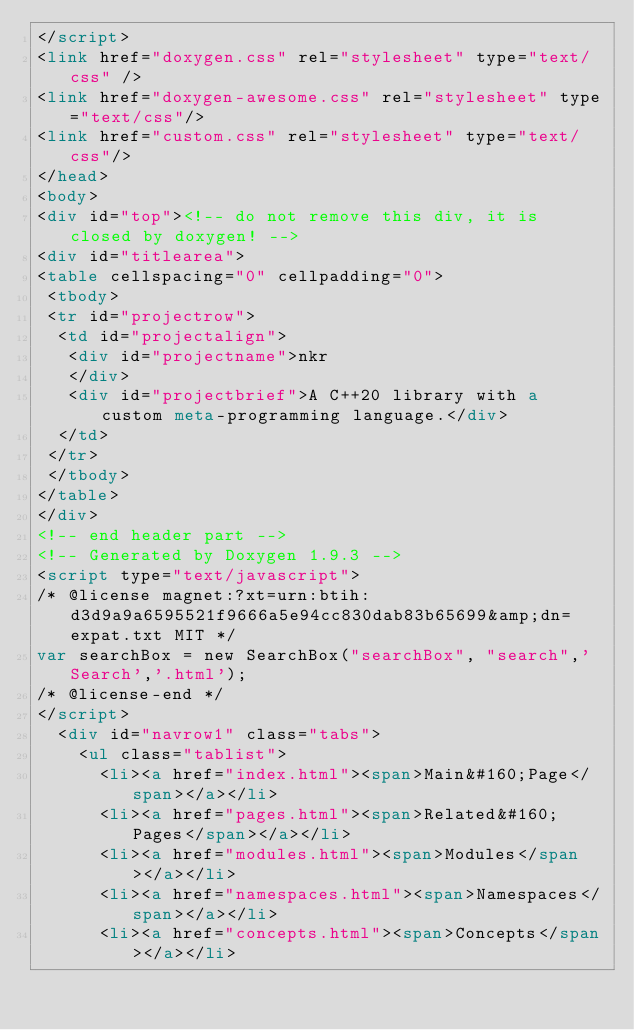<code> <loc_0><loc_0><loc_500><loc_500><_HTML_></script>
<link href="doxygen.css" rel="stylesheet" type="text/css" />
<link href="doxygen-awesome.css" rel="stylesheet" type="text/css"/>
<link href="custom.css" rel="stylesheet" type="text/css"/>
</head>
<body>
<div id="top"><!-- do not remove this div, it is closed by doxygen! -->
<div id="titlearea">
<table cellspacing="0" cellpadding="0">
 <tbody>
 <tr id="projectrow">
  <td id="projectalign">
   <div id="projectname">nkr
   </div>
   <div id="projectbrief">A C++20 library with a custom meta-programming language.</div>
  </td>
 </tr>
 </tbody>
</table>
</div>
<!-- end header part -->
<!-- Generated by Doxygen 1.9.3 -->
<script type="text/javascript">
/* @license magnet:?xt=urn:btih:d3d9a9a6595521f9666a5e94cc830dab83b65699&amp;dn=expat.txt MIT */
var searchBox = new SearchBox("searchBox", "search",'Search','.html');
/* @license-end */
</script>
  <div id="navrow1" class="tabs">
    <ul class="tablist">
      <li><a href="index.html"><span>Main&#160;Page</span></a></li>
      <li><a href="pages.html"><span>Related&#160;Pages</span></a></li>
      <li><a href="modules.html"><span>Modules</span></a></li>
      <li><a href="namespaces.html"><span>Namespaces</span></a></li>
      <li><a href="concepts.html"><span>Concepts</span></a></li></code> 